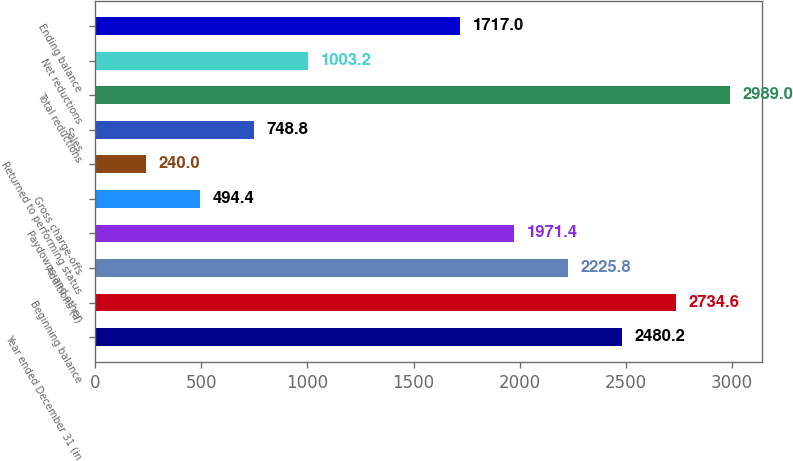Convert chart. <chart><loc_0><loc_0><loc_500><loc_500><bar_chart><fcel>Year ended December 31 (in<fcel>Beginning balance<fcel>Additions (a)<fcel>Paydowns and other<fcel>Gross charge-offs<fcel>Returned to performing status<fcel>Sales<fcel>Total reductions<fcel>Net reductions<fcel>Ending balance<nl><fcel>2480.2<fcel>2734.6<fcel>2225.8<fcel>1971.4<fcel>494.4<fcel>240<fcel>748.8<fcel>2989<fcel>1003.2<fcel>1717<nl></chart> 